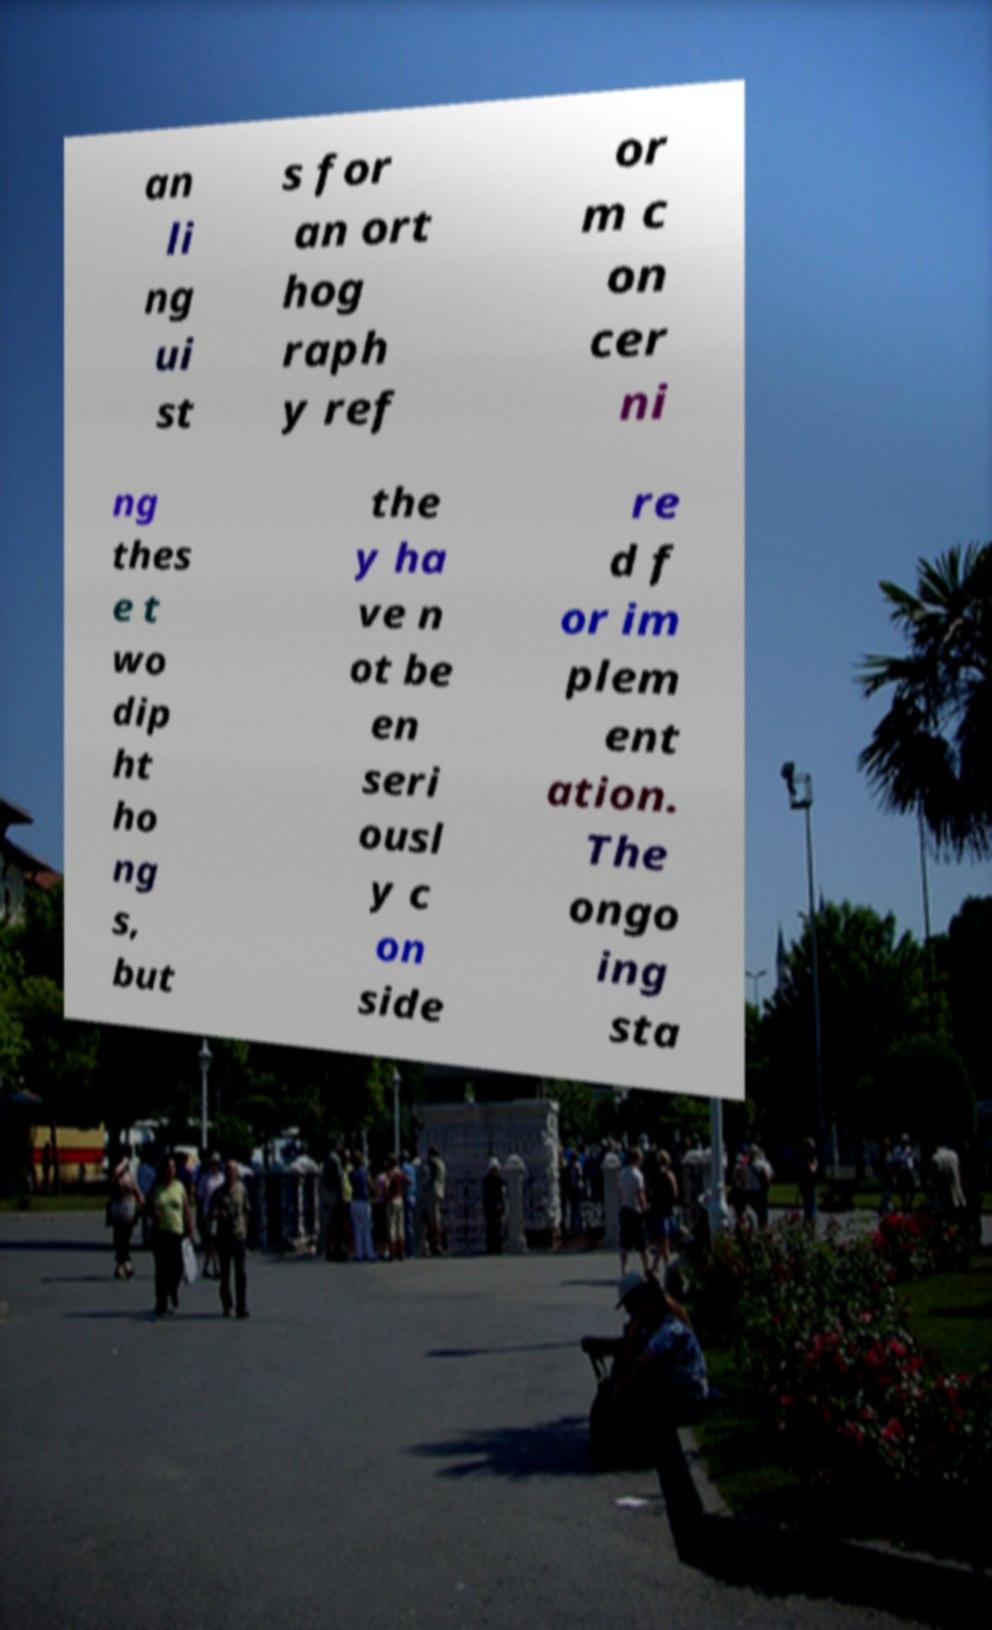I need the written content from this picture converted into text. Can you do that? an li ng ui st s for an ort hog raph y ref or m c on cer ni ng thes e t wo dip ht ho ng s, but the y ha ve n ot be en seri ousl y c on side re d f or im plem ent ation. The ongo ing sta 